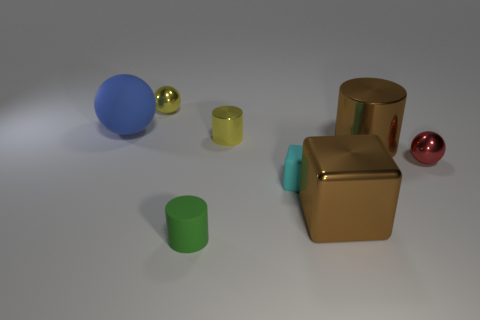Subtract all metal balls. How many balls are left? 1 Subtract all yellow cylinders. How many cylinders are left? 2 Subtract all cylinders. How many objects are left? 5 Add 1 cyan cubes. How many objects exist? 9 Subtract 2 cylinders. How many cylinders are left? 1 Subtract 0 purple spheres. How many objects are left? 8 Subtract all green cylinders. Subtract all green spheres. How many cylinders are left? 2 Subtract all green cylinders. How many yellow balls are left? 1 Subtract all tiny blue metallic cylinders. Subtract all metal cylinders. How many objects are left? 6 Add 5 tiny matte cubes. How many tiny matte cubes are left? 6 